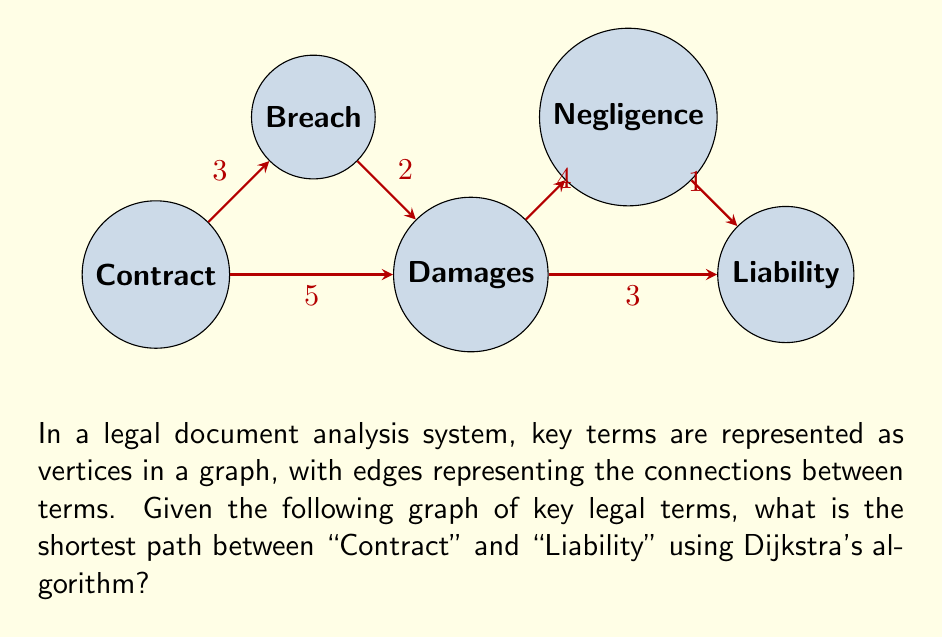Help me with this question. To find the shortest path between "Contract" and "Liability" using Dijkstra's algorithm, we follow these steps:

1) Initialize:
   - Set distance to Contract (start) as 0
   - Set distances to all other vertices as infinity
   - Set all vertices as unvisited

2) For the current vertex (starting with Contract), consider all unvisited neighbors and calculate their tentative distances:
   - Contract to Breach: 3
   - Contract to Damages: 5

3) Mark Contract as visited. Current shortest paths:
   Contract -> Breach: 3
   Contract -> Damages: 5
   Others: infinity

4) Select Breach as the new current vertex (lowest tentative distance among unvisited vertices).
   - Breach to Damages: 3 + 2 = 5 (no change to Damages)

5) Mark Breach as visited. Move to Damages (next lowest tentative distance).
   - Damages to Negligence: 5 + 4 = 9
   - Damages to Liability: 5 + 3 = 8

6) Mark Damages as visited. Move to Liability (next lowest tentative distance).

7) Algorithm terminates as we've reached the target vertex (Liability).

The shortest path is: Contract -> Damages -> Liability
The total distance is: 5 + 3 = 8
Answer: Contract -> Damages -> Liability, distance = 8 